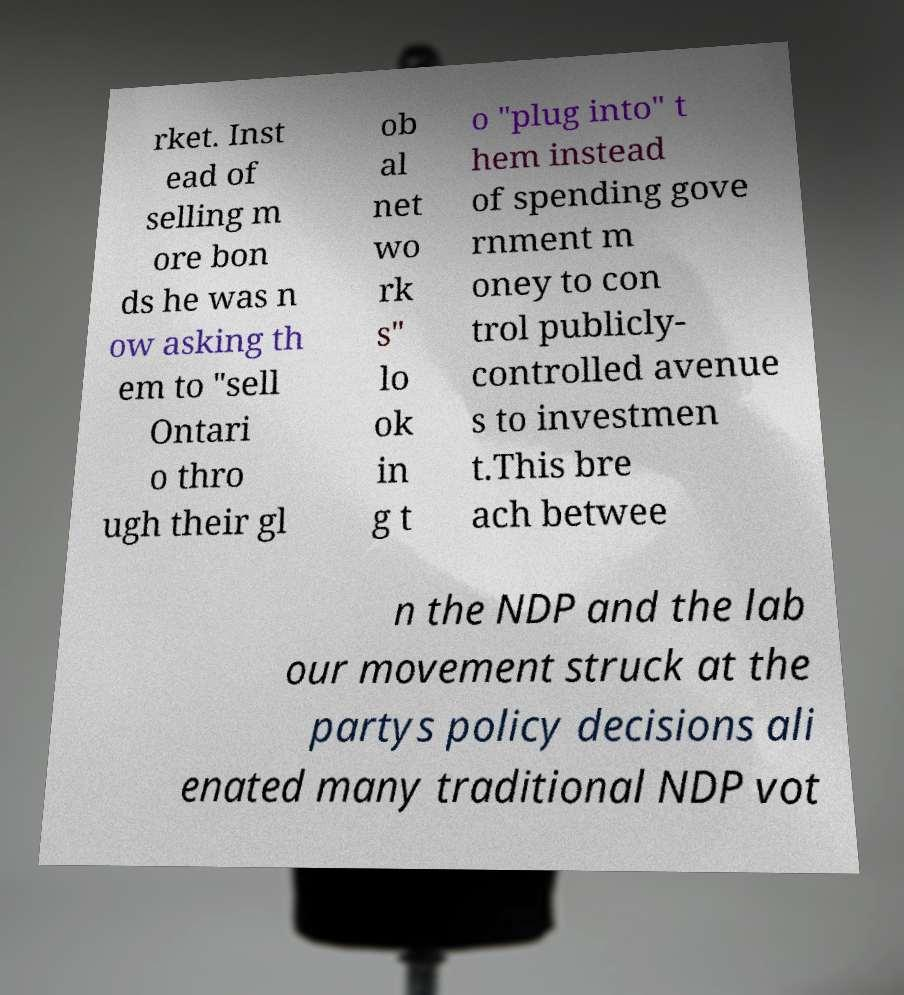Can you accurately transcribe the text from the provided image for me? rket. Inst ead of selling m ore bon ds he was n ow asking th em to "sell Ontari o thro ugh their gl ob al net wo rk s" lo ok in g t o "plug into" t hem instead of spending gove rnment m oney to con trol publicly- controlled avenue s to investmen t.This bre ach betwee n the NDP and the lab our movement struck at the partys policy decisions ali enated many traditional NDP vot 